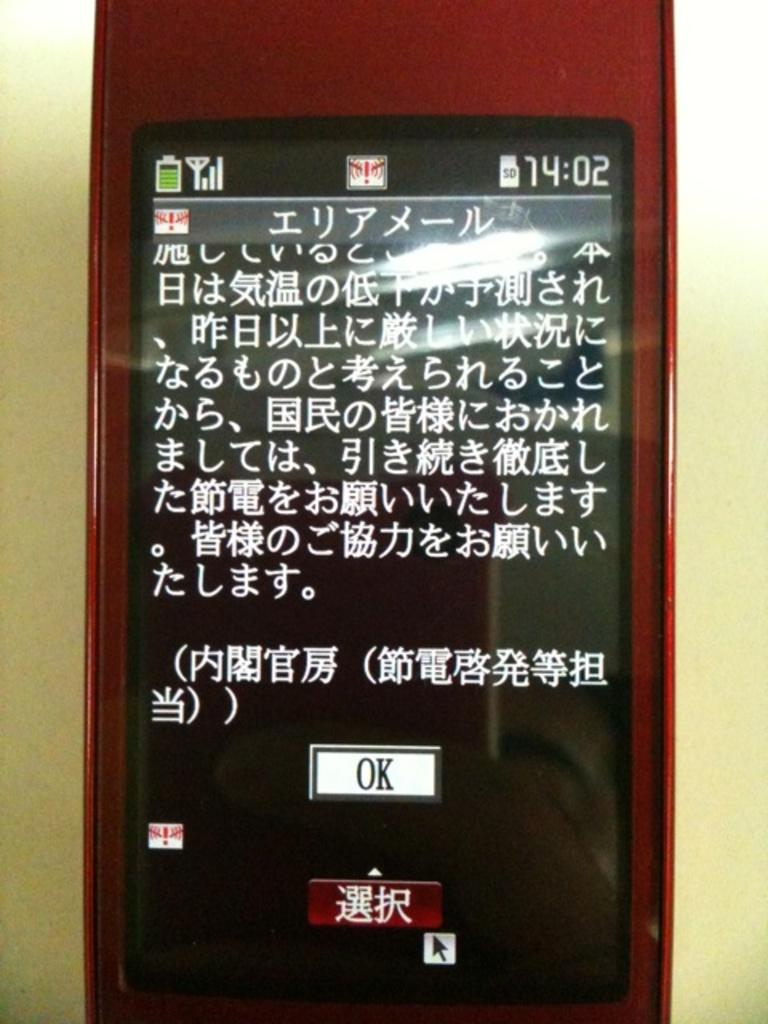<image>
Present a compact description of the photo's key features. a cellphone with chinese characters and a white button labeled OK at the bottom center 